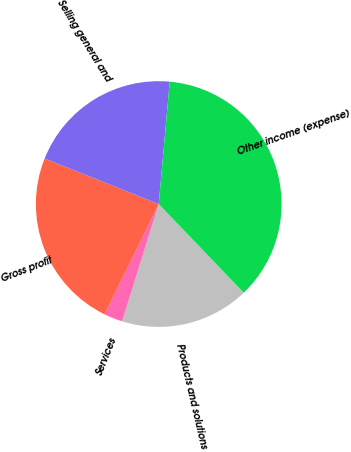<chart> <loc_0><loc_0><loc_500><loc_500><pie_chart><fcel>Products and solutions<fcel>Services<fcel>Gross profit<fcel>Selling general and<fcel>Other income (expense)<nl><fcel>16.98%<fcel>2.45%<fcel>23.78%<fcel>20.38%<fcel>36.41%<nl></chart> 